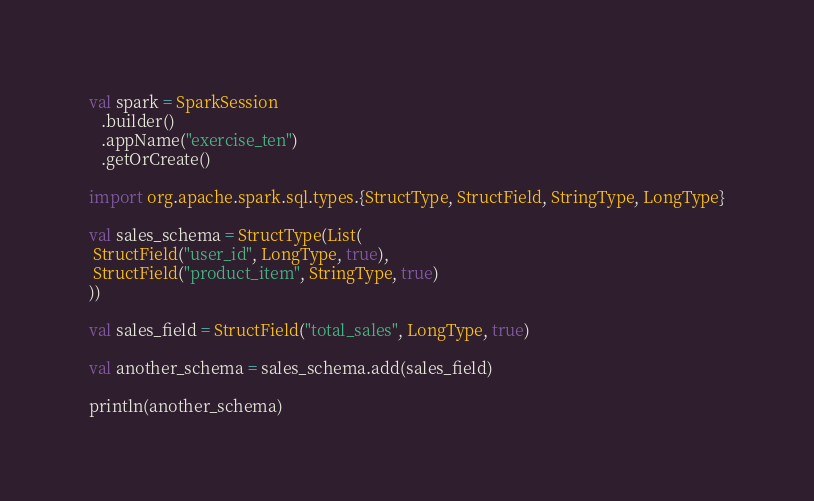<code> <loc_0><loc_0><loc_500><loc_500><_Scala_>val spark = SparkSession
   .builder()
   .appName("exercise_ten")
   .getOrCreate()

import org.apache.spark.sql.types.{StructType, StructField, StringType, LongType}

val sales_schema = StructType(List(
 StructField("user_id", LongType, true),
 StructField("product_item", StringType, true)
))

val sales_field = StructField("total_sales", LongType, true)

val another_schema = sales_schema.add(sales_field)

println(another_schema)
</code> 